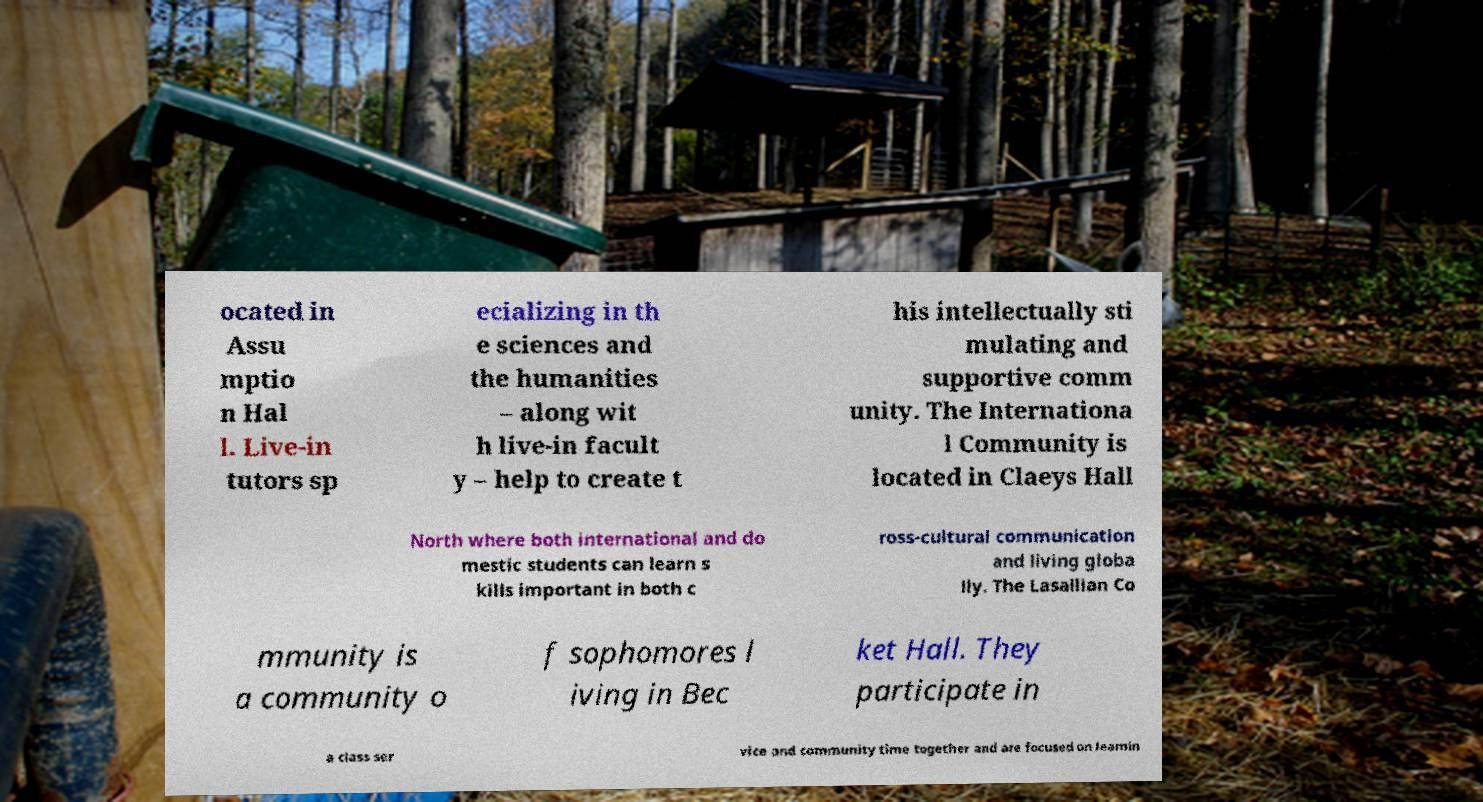I need the written content from this picture converted into text. Can you do that? ocated in Assu mptio n Hal l. Live-in tutors sp ecializing in th e sciences and the humanities – along wit h live-in facult y – help to create t his intellectually sti mulating and supportive comm unity. The Internationa l Community is located in Claeys Hall North where both international and do mestic students can learn s kills important in both c ross-cultural communication and living globa lly. The Lasallian Co mmunity is a community o f sophomores l iving in Bec ket Hall. They participate in a class ser vice and community time together and are focused on learnin 